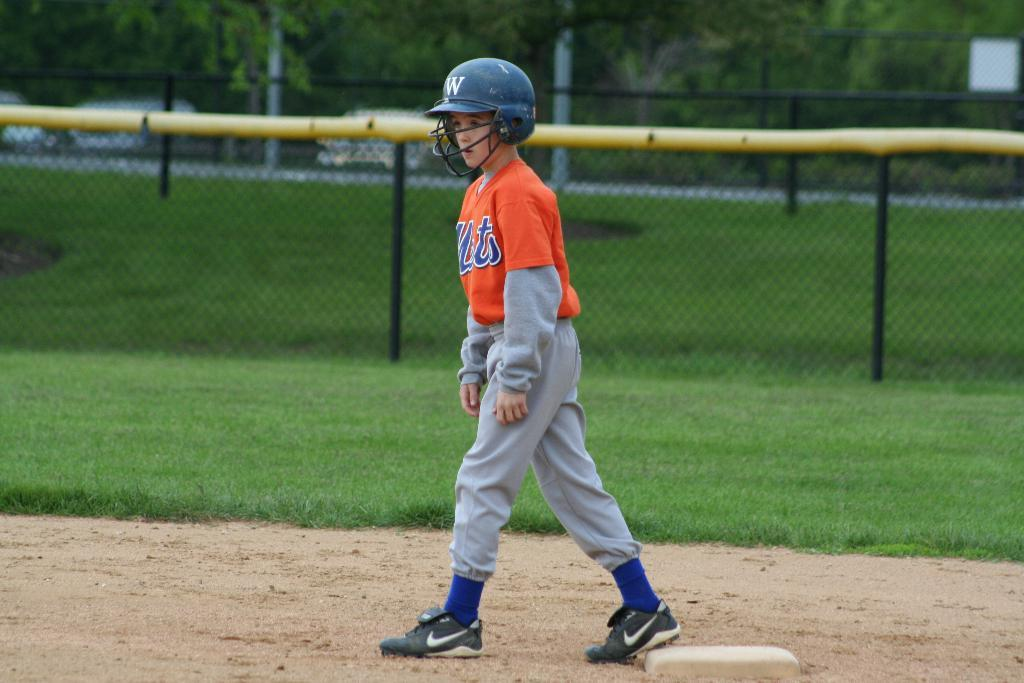What is the main subject of the image? There is a person standing in the center of the image. What can be seen in the background of the image? There is a fence and trees in the background of the image. What type of vegetation is visible in the image? Grass is visible in the image. What is the name of the person holding the sack of beans in the image? There is no person holding a sack of beans in the image; the main subject is a person standing in the center, and there is no mention of beans or a sack. 